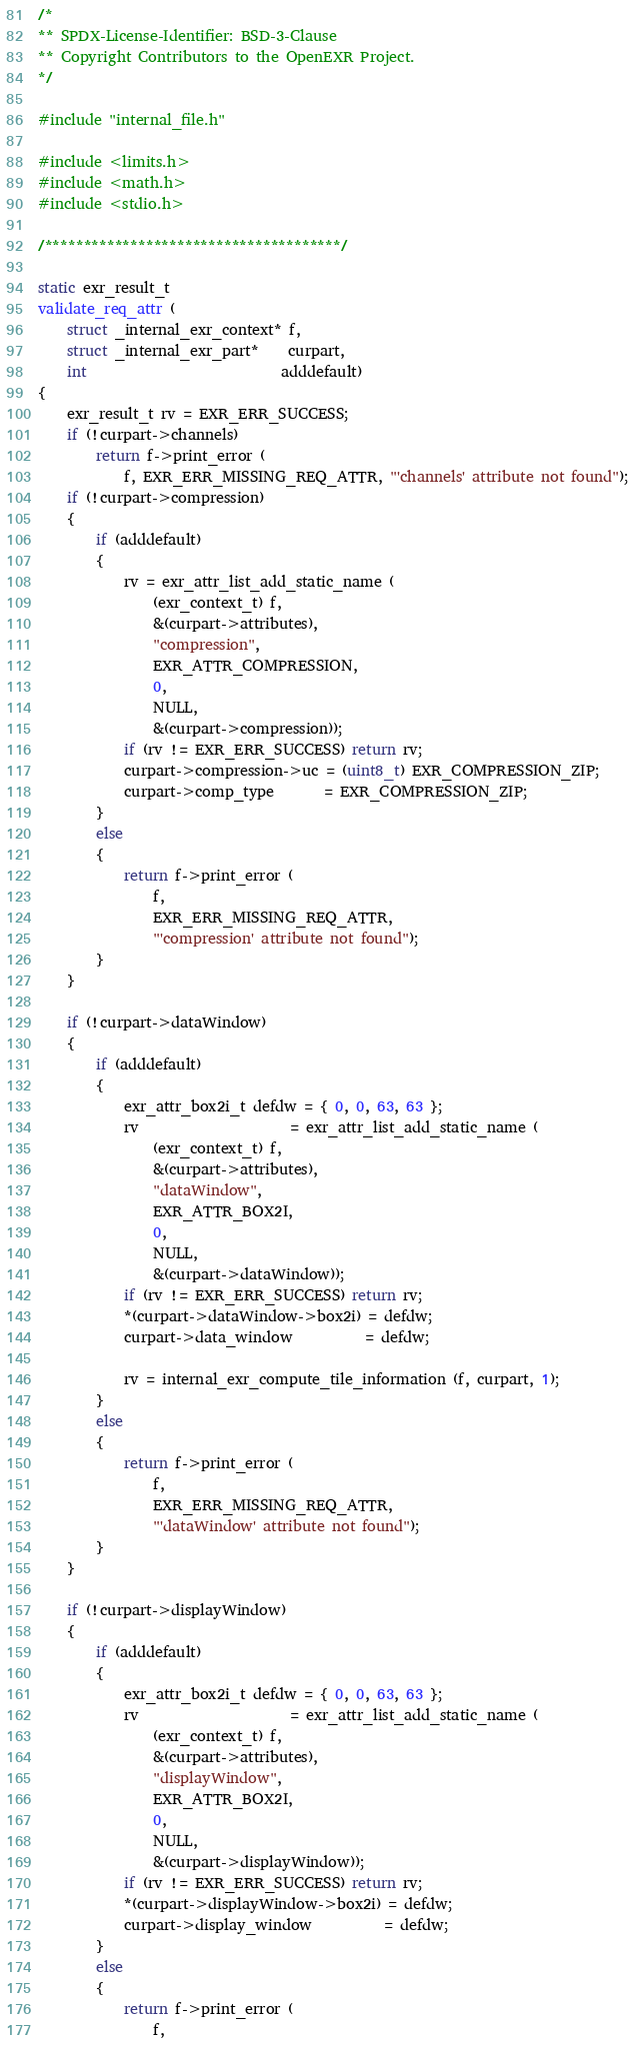<code> <loc_0><loc_0><loc_500><loc_500><_C_>/*
** SPDX-License-Identifier: BSD-3-Clause
** Copyright Contributors to the OpenEXR Project.
*/

#include "internal_file.h"

#include <limits.h>
#include <math.h>
#include <stdio.h>

/**************************************/

static exr_result_t
validate_req_attr (
    struct _internal_exr_context* f,
    struct _internal_exr_part*    curpart,
    int                           adddefault)
{
    exr_result_t rv = EXR_ERR_SUCCESS;
    if (!curpart->channels)
        return f->print_error (
            f, EXR_ERR_MISSING_REQ_ATTR, "'channels' attribute not found");
    if (!curpart->compression)
    {
        if (adddefault)
        {
            rv = exr_attr_list_add_static_name (
                (exr_context_t) f,
                &(curpart->attributes),
                "compression",
                EXR_ATTR_COMPRESSION,
                0,
                NULL,
                &(curpart->compression));
            if (rv != EXR_ERR_SUCCESS) return rv;
            curpart->compression->uc = (uint8_t) EXR_COMPRESSION_ZIP;
            curpart->comp_type       = EXR_COMPRESSION_ZIP;
        }
        else
        {
            return f->print_error (
                f,
                EXR_ERR_MISSING_REQ_ATTR,
                "'compression' attribute not found");
        }
    }

    if (!curpart->dataWindow)
    {
        if (adddefault)
        {
            exr_attr_box2i_t defdw = { 0, 0, 63, 63 };
            rv                     = exr_attr_list_add_static_name (
                (exr_context_t) f,
                &(curpart->attributes),
                "dataWindow",
                EXR_ATTR_BOX2I,
                0,
                NULL,
                &(curpart->dataWindow));
            if (rv != EXR_ERR_SUCCESS) return rv;
            *(curpart->dataWindow->box2i) = defdw;
            curpart->data_window          = defdw;

            rv = internal_exr_compute_tile_information (f, curpart, 1);
        }
        else
        {
            return f->print_error (
                f,
                EXR_ERR_MISSING_REQ_ATTR,
                "'dataWindow' attribute not found");
        }
    }

    if (!curpart->displayWindow)
    {
        if (adddefault)
        {
            exr_attr_box2i_t defdw = { 0, 0, 63, 63 };
            rv                     = exr_attr_list_add_static_name (
                (exr_context_t) f,
                &(curpart->attributes),
                "displayWindow",
                EXR_ATTR_BOX2I,
                0,
                NULL,
                &(curpart->displayWindow));
            if (rv != EXR_ERR_SUCCESS) return rv;
            *(curpart->displayWindow->box2i) = defdw;
            curpart->display_window          = defdw;
        }
        else
        {
            return f->print_error (
                f,</code> 